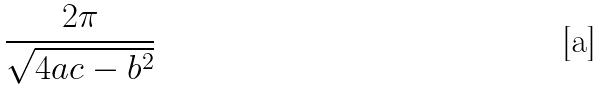<formula> <loc_0><loc_0><loc_500><loc_500>\frac { 2 \pi } { \sqrt { 4 a c - b ^ { 2 } } }</formula> 